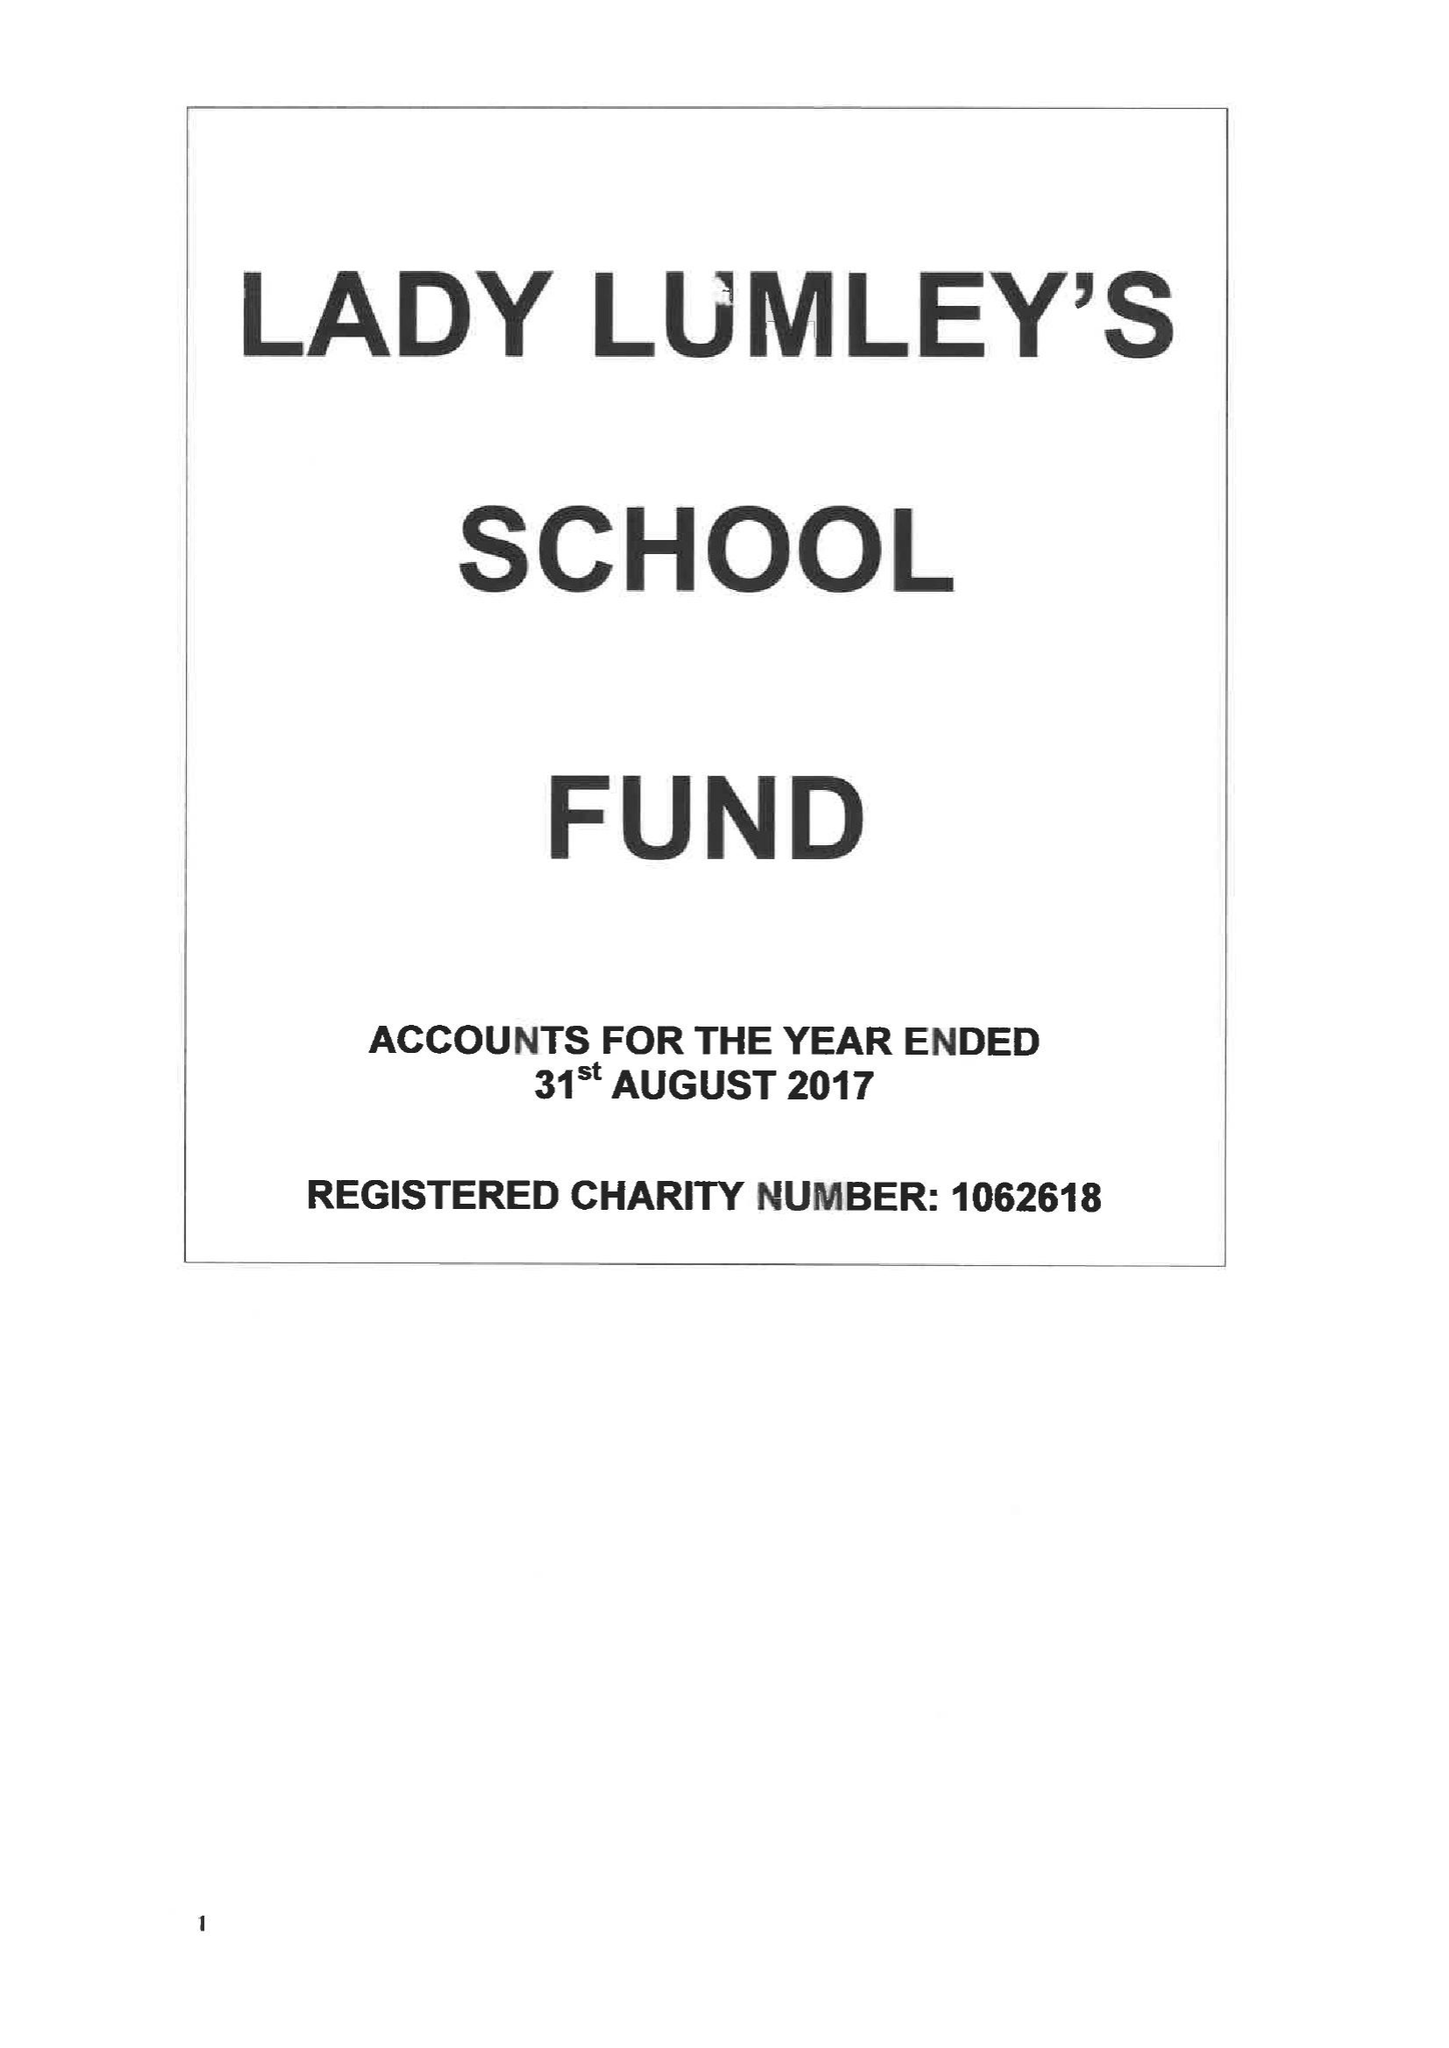What is the value for the address__street_line?
Answer the question using a single word or phrase. SWAINSEA LANE 